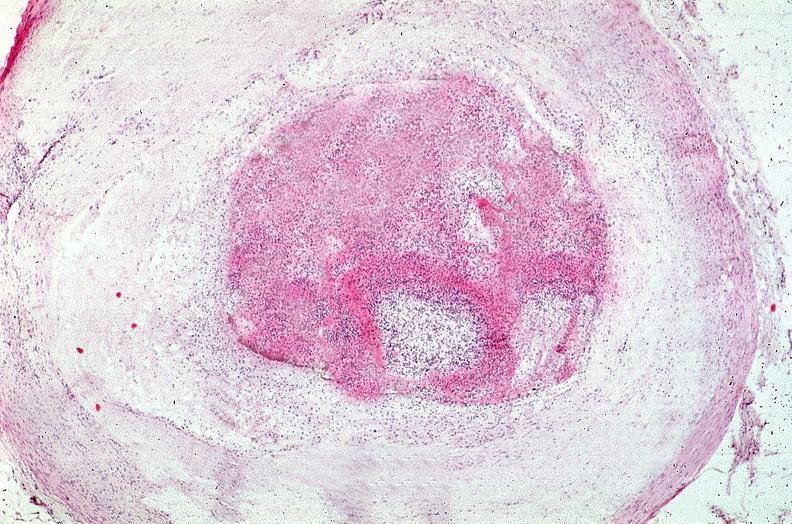s cranial artery present?
Answer the question using a single word or phrase. No 